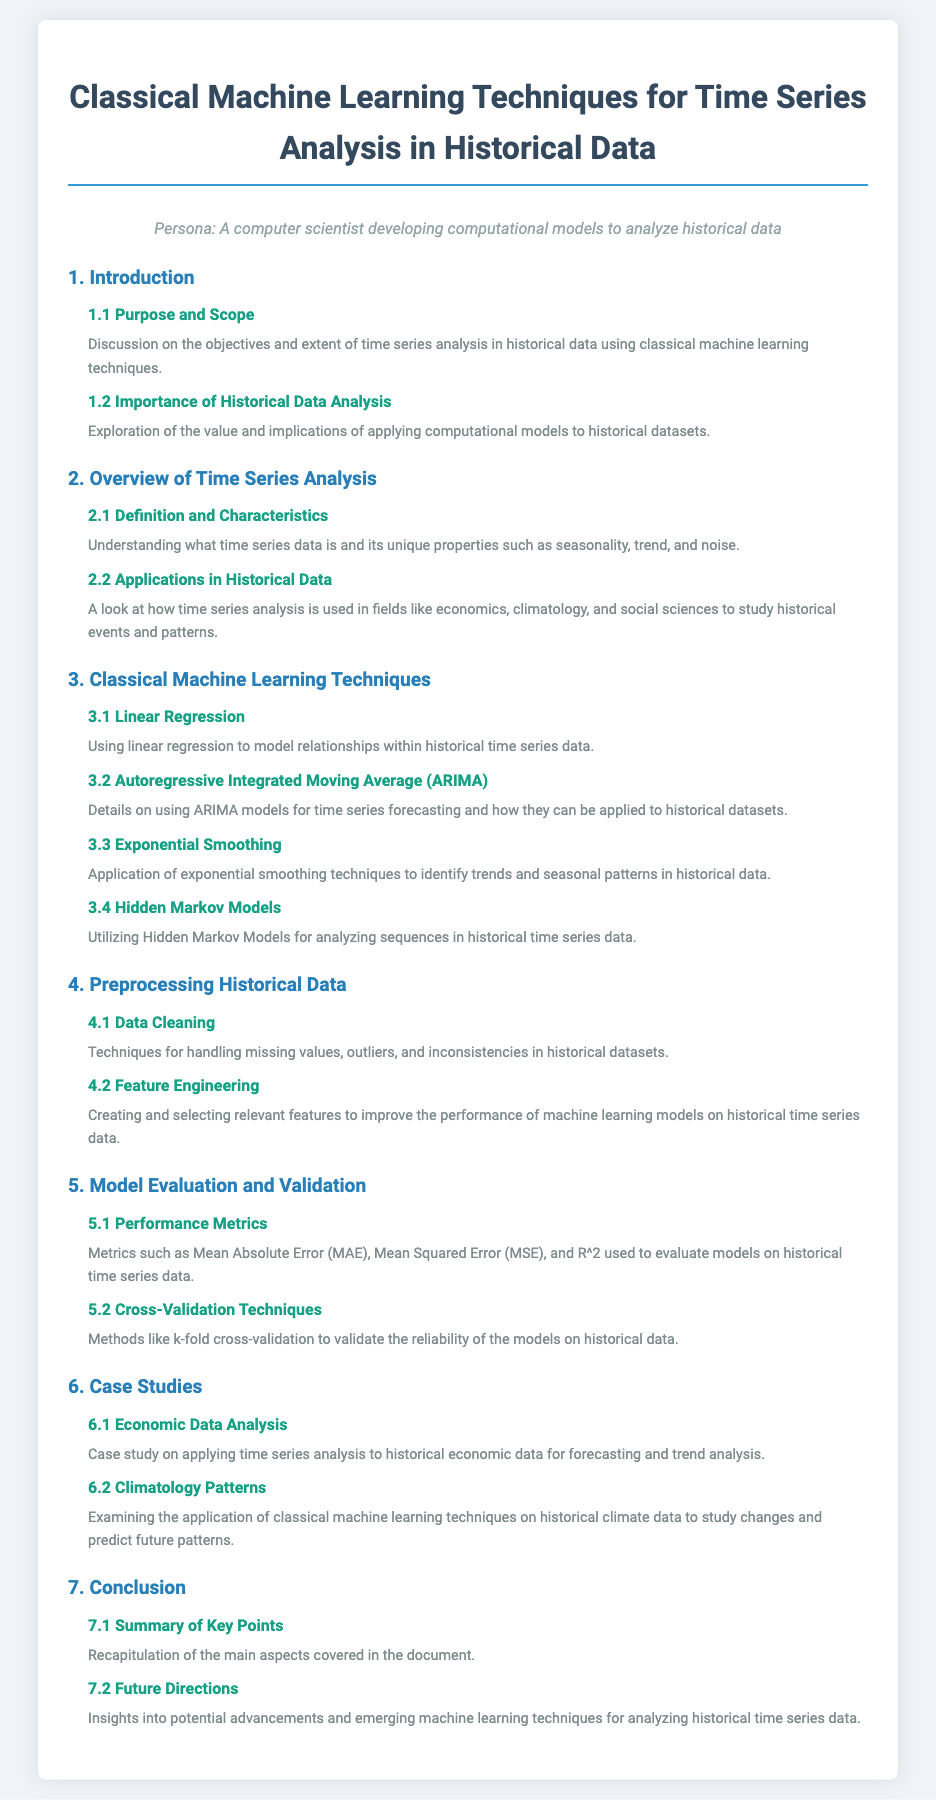what is the purpose of the document? The purpose of the document is centered on discussing objectives and extent of time series analysis in historical data using classical machine learning techniques.
Answer: classical machine learning techniques what is discussed in section 5.1? Section 5.1 discusses metrics used to evaluate models on historical time series data.
Answer: Performance Metrics which classical machine learning technique is used for forecasting? ARIMA is detailed as a classical machine learning technique used for time series forecasting.
Answer: ARIMA how many main sections are there in the document? The document has a total of seven main sections.
Answer: seven what is one application of time series analysis mentioned? One application mentioned is its use in economics to study historical events and patterns.
Answer: economics which technique is applied to identify trends and seasonal patterns? Exponential smoothing techniques are applied to identify trends and seasonal patterns.
Answer: Exponential Smoothing what is the title of section 6.2? The title of section 6.2 is 'Climatology Patterns.'
Answer: Climatology Patterns what does section 4.1 cover? Section 4.1 covers techniques for handling missing values, outliers, and inconsistencies in historical datasets.
Answer: Data Cleaning 